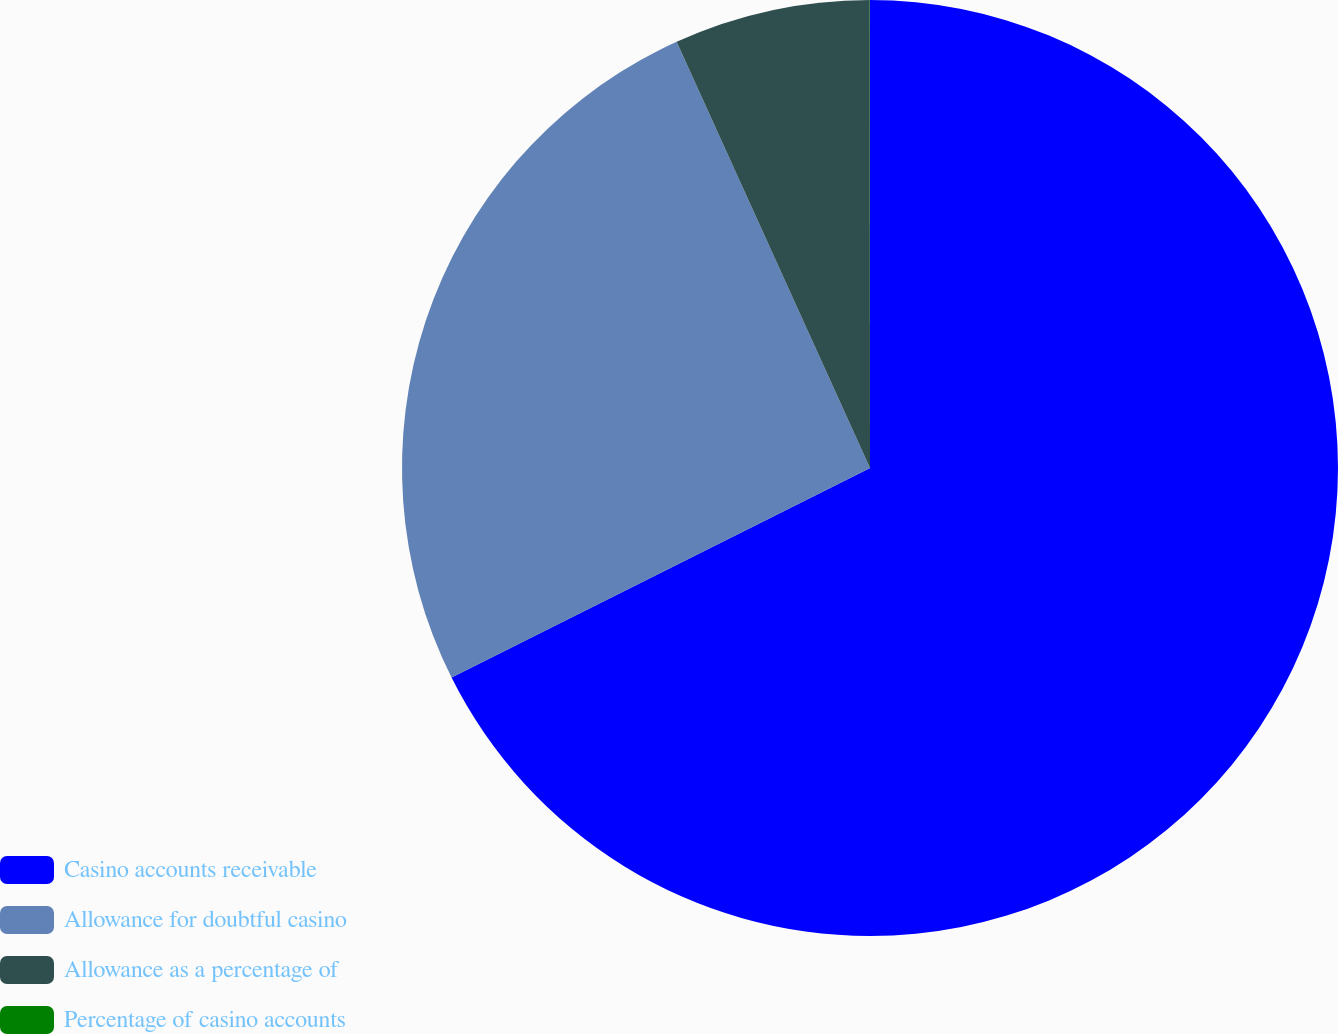Convert chart to OTSL. <chart><loc_0><loc_0><loc_500><loc_500><pie_chart><fcel>Casino accounts receivable<fcel>Allowance for doubtful casino<fcel>Allowance as a percentage of<fcel>Percentage of casino accounts<nl><fcel>67.61%<fcel>25.61%<fcel>6.77%<fcel>0.01%<nl></chart> 